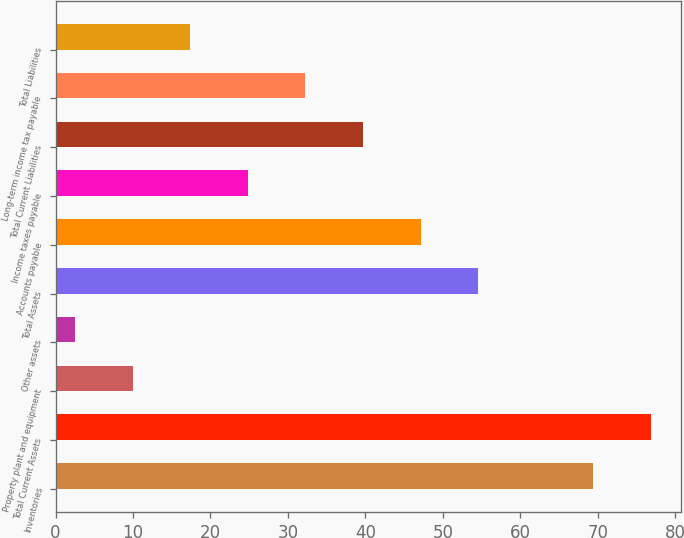<chart> <loc_0><loc_0><loc_500><loc_500><bar_chart><fcel>Inventories<fcel>Total Current Assets<fcel>Property plant and equipment<fcel>Other assets<fcel>Total Assets<fcel>Accounts payable<fcel>Income taxes payable<fcel>Total Current Liabilities<fcel>Long-term income tax payable<fcel>Total Liabilities<nl><fcel>69.46<fcel>76.9<fcel>9.94<fcel>2.5<fcel>54.58<fcel>47.14<fcel>24.82<fcel>39.7<fcel>32.26<fcel>17.38<nl></chart> 